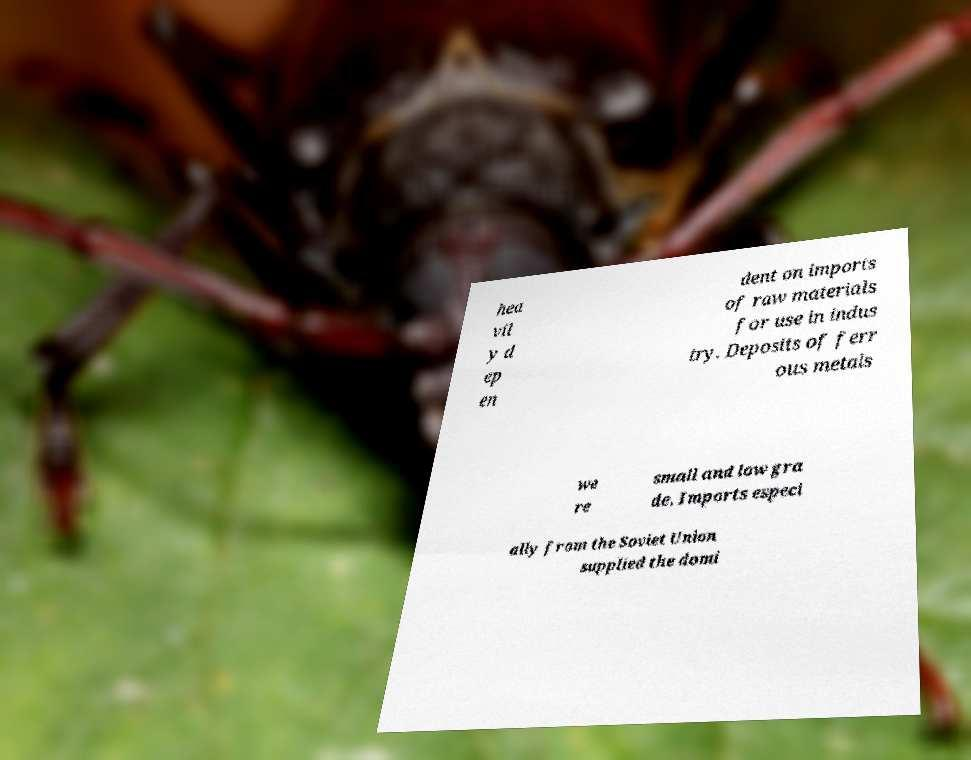There's text embedded in this image that I need extracted. Can you transcribe it verbatim? hea vil y d ep en dent on imports of raw materials for use in indus try. Deposits of ferr ous metals we re small and low gra de. Imports especi ally from the Soviet Union supplied the domi 